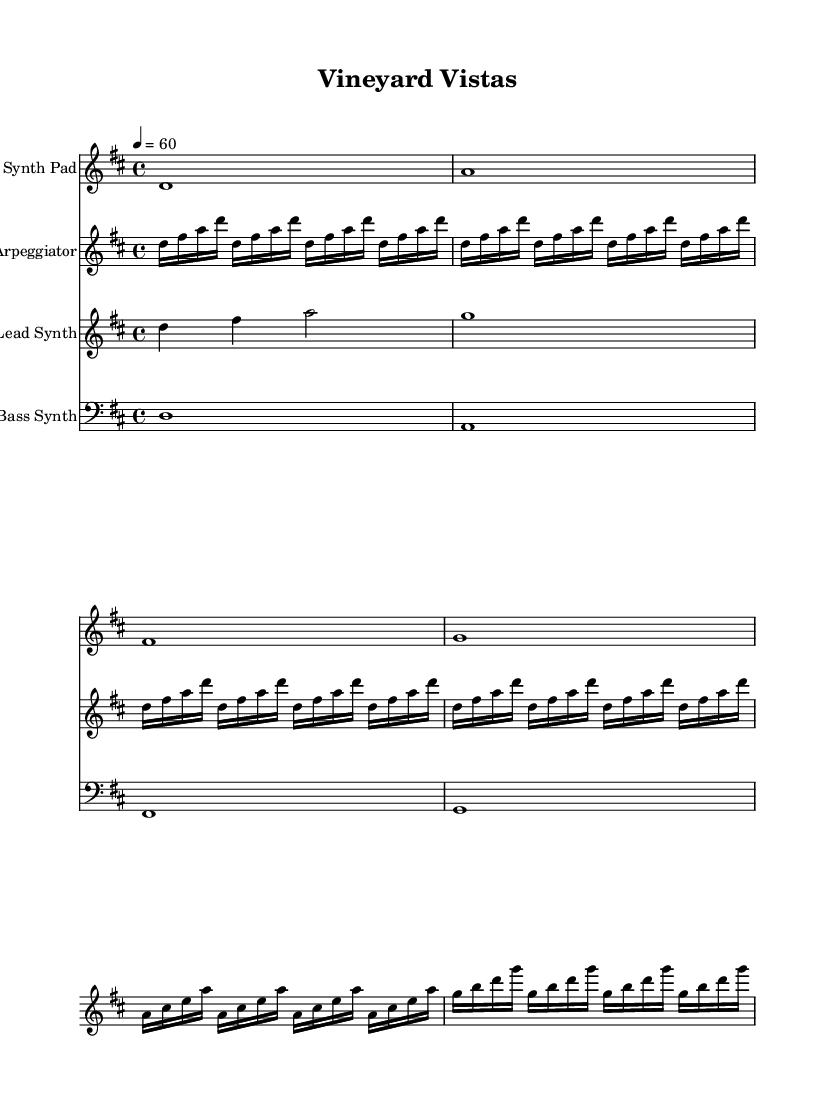What is the key signature of this music? The key signature is located at the beginning of the staff, which shows two sharps. This indicates the key of D major.
Answer: D major What is the time signature of this music? The time signature is found at the beginning of the score, which reads "4/4". This means there are four beats in each measure and a quarter note gets one beat.
Answer: 4/4 What is the tempo marking of this sheet music? The tempo marking is indicated by "4 = 60", which specifies the speed of the music. It tells us that there are 60 beats per minute.
Answer: 60 How many measures are there in the lead synth part? By counting the measures in the lead synth part, we observe there are five measures total based on the notation presented.
Answer: 5 What instruments are used in this composition? The instruments are indicated at the beginning of each staff: Synth Pad, Arpeggiator, Lead Synth, and Bass Synth.
Answer: Synth Pad, Arpeggiator, Lead Synth, Bass Synth What is the note pattern in the arpeggiator section? The arpeggiator section consists of repeated note groupings, specifically playing the notes D, F#, A, and D in a sequence, which defines the style typical of ambient electronic music.
Answer: D, F#, A, D 